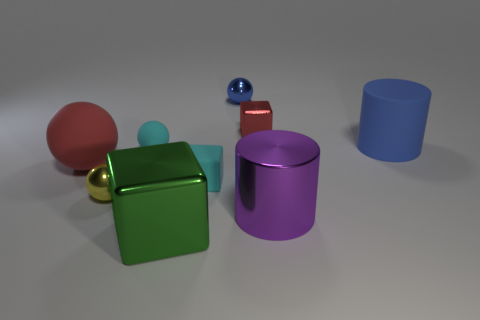Are there any matte objects in front of the red shiny object?
Your answer should be compact. Yes. There is a large matte ball; does it have the same color as the shiny block that is behind the small yellow object?
Keep it short and to the point. Yes. The cube that is in front of the shiny object to the left of the shiny block that is left of the rubber cube is what color?
Provide a succinct answer. Green. Is there a tiny cyan object of the same shape as the yellow object?
Offer a very short reply. Yes. There is a metallic block that is the same size as the yellow metal object; what is its color?
Ensure brevity in your answer.  Red. What is the tiny cube on the left side of the tiny red block made of?
Give a very brief answer. Rubber. Do the red object that is in front of the tiny metal cube and the cyan thing left of the green block have the same shape?
Ensure brevity in your answer.  Yes. Are there the same number of yellow balls in front of the tiny cyan matte cube and red matte objects?
Give a very brief answer. Yes. How many large purple cylinders are the same material as the big blue object?
Give a very brief answer. 0. The tiny ball that is made of the same material as the yellow object is what color?
Make the answer very short. Blue. 